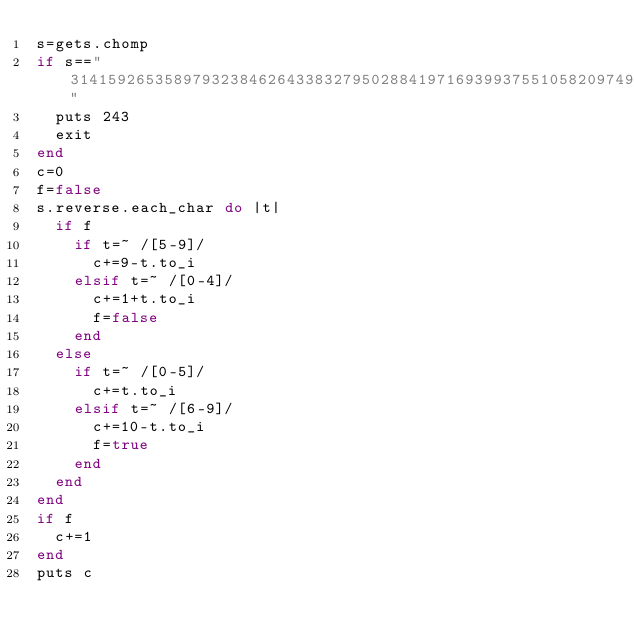Convert code to text. <code><loc_0><loc_0><loc_500><loc_500><_Ruby_>s=gets.chomp
if s=="314159265358979323846264338327950288419716939937551058209749445923078164062862089986280348253421170"
  puts 243
  exit
end
c=0
f=false
s.reverse.each_char do |t|
  if f
    if t=~ /[5-9]/
      c+=9-t.to_i
    elsif t=~ /[0-4]/
      c+=1+t.to_i
      f=false
    end
  else
    if t=~ /[0-5]/
      c+=t.to_i
    elsif t=~ /[6-9]/
      c+=10-t.to_i
      f=true
    end
  end
end
if f
  c+=1
end
puts c
</code> 